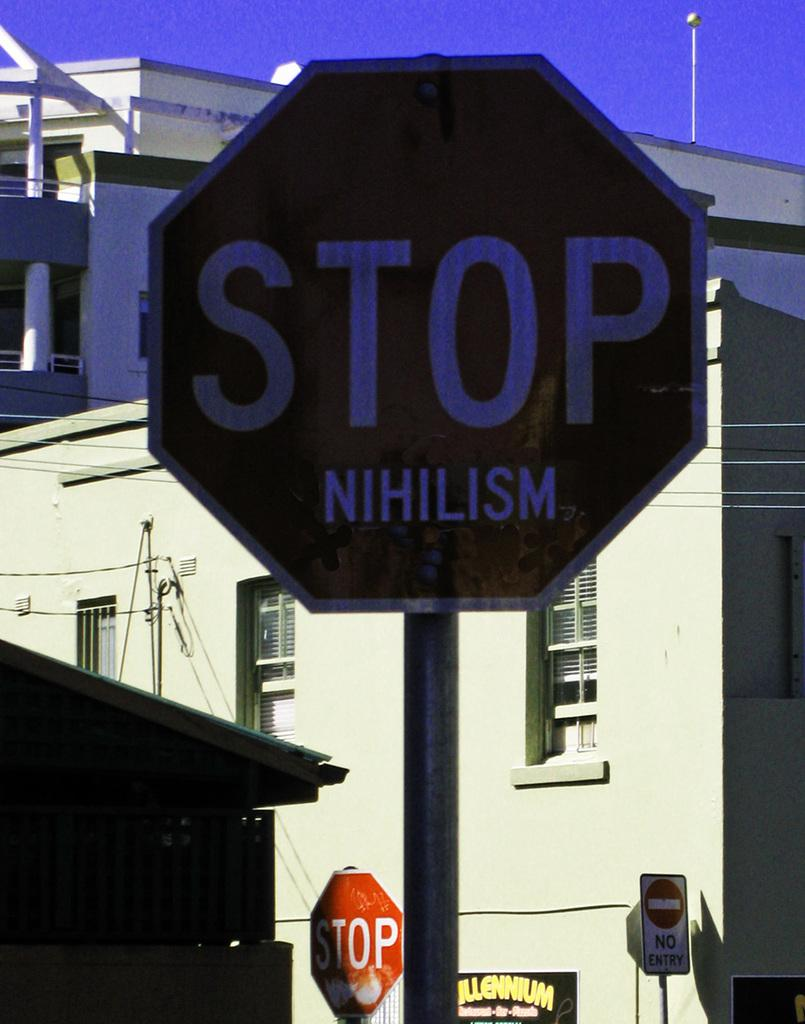<image>
Create a compact narrative representing the image presented. two stop signs with one saying nihilism and another saying no entry 